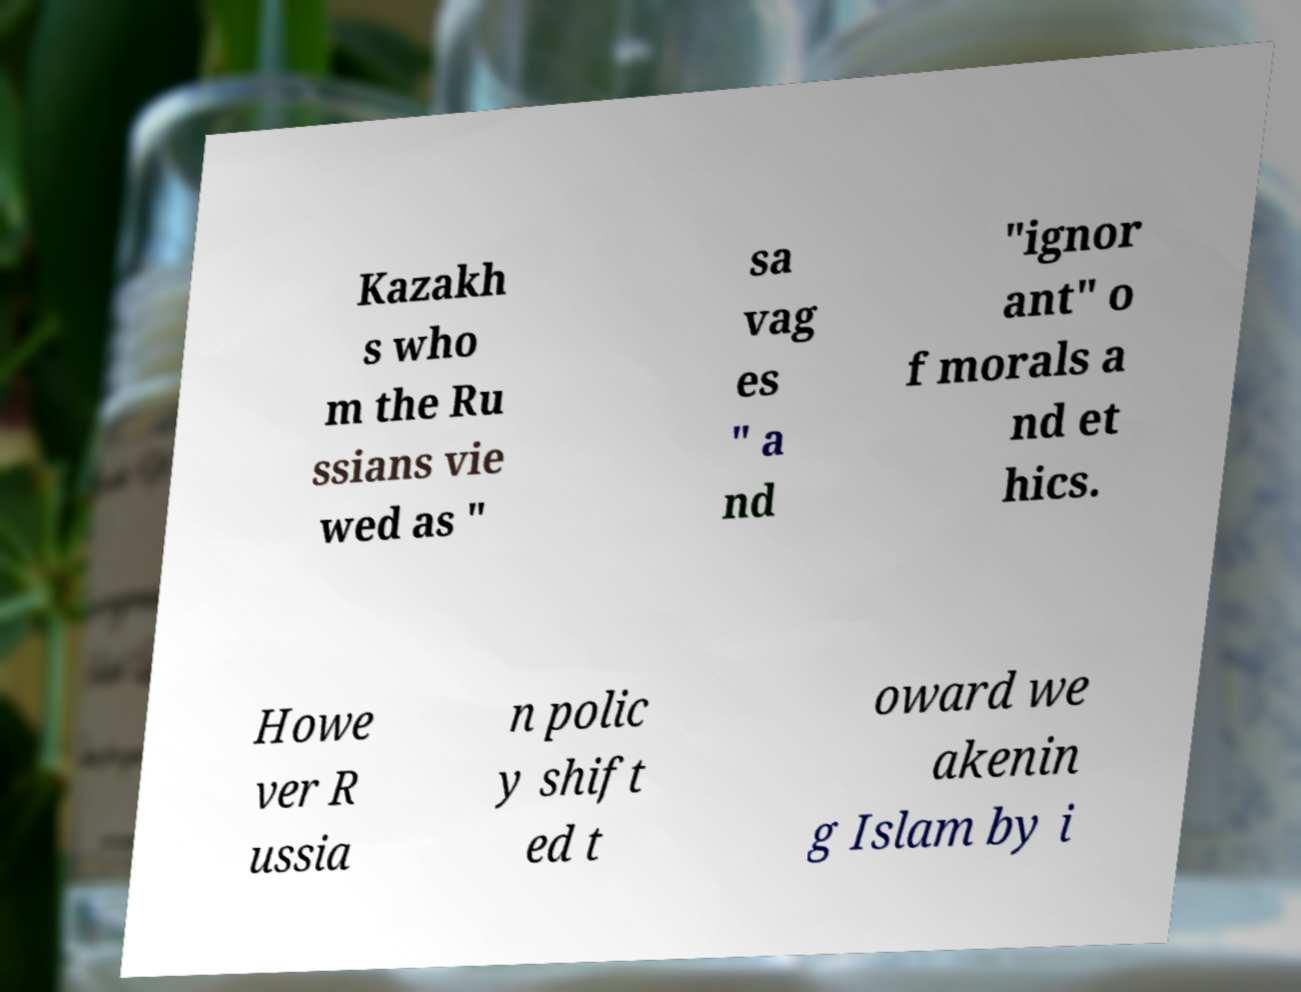Can you read and provide the text displayed in the image?This photo seems to have some interesting text. Can you extract and type it out for me? Kazakh s who m the Ru ssians vie wed as " sa vag es " a nd "ignor ant" o f morals a nd et hics. Howe ver R ussia n polic y shift ed t oward we akenin g Islam by i 